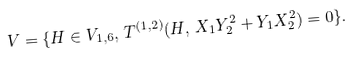<formula> <loc_0><loc_0><loc_500><loc_500>V = \{ H \in V _ { 1 , 6 } , \, T ^ { ( 1 , 2 ) } ( H , \, X _ { 1 } Y _ { 2 } ^ { 2 } + Y _ { 1 } X _ { 2 } ^ { 2 } ) = 0 \} .</formula> 